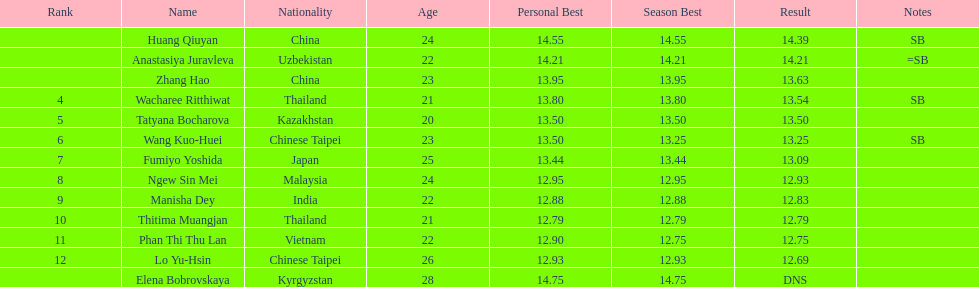How many contestants were from thailand? 2. 